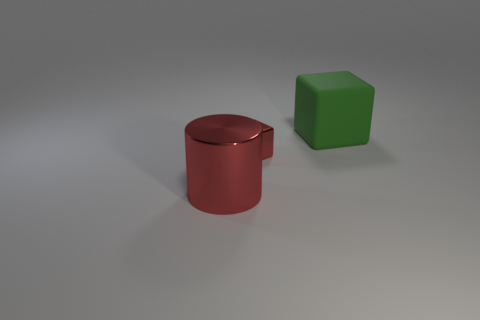Add 3 tiny green blocks. How many objects exist? 6 Subtract all cylinders. How many objects are left? 2 Subtract 1 red blocks. How many objects are left? 2 Subtract all big gray shiny cubes. Subtract all big red cylinders. How many objects are left? 2 Add 1 large matte objects. How many large matte objects are left? 2 Add 3 big blue cylinders. How many big blue cylinders exist? 3 